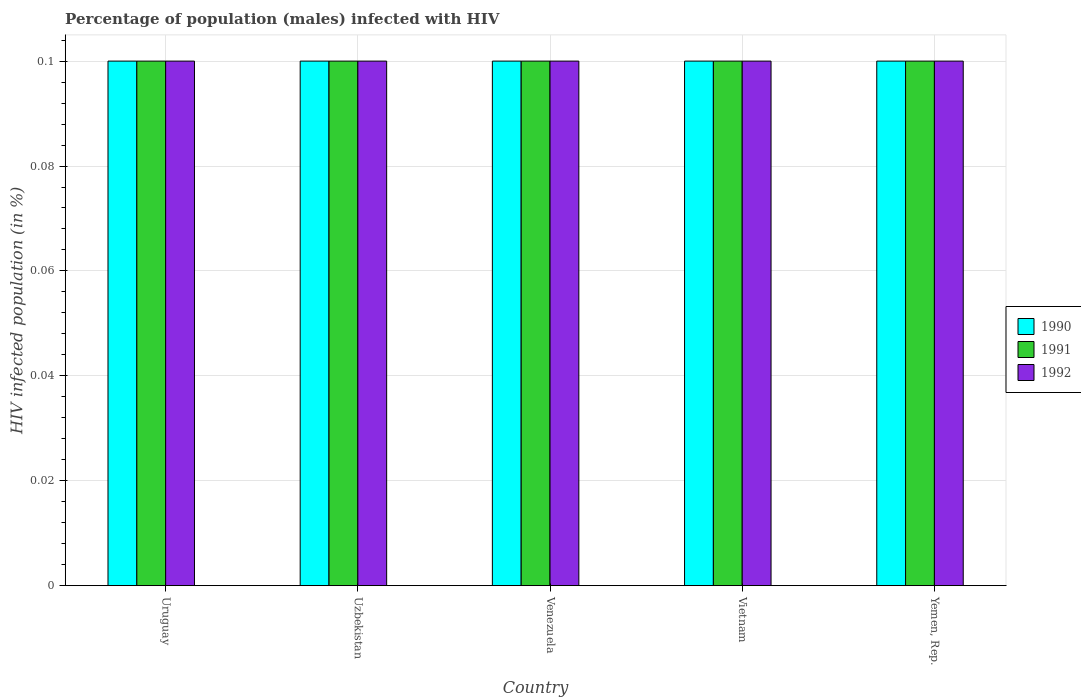How many different coloured bars are there?
Keep it short and to the point. 3. How many bars are there on the 1st tick from the left?
Keep it short and to the point. 3. What is the label of the 4th group of bars from the left?
Offer a terse response. Vietnam. What is the percentage of HIV infected male population in 1991 in Uruguay?
Make the answer very short. 0.1. Across all countries, what is the maximum percentage of HIV infected male population in 1991?
Offer a terse response. 0.1. In which country was the percentage of HIV infected male population in 1991 maximum?
Offer a very short reply. Uruguay. In which country was the percentage of HIV infected male population in 1991 minimum?
Ensure brevity in your answer.  Uruguay. What is the difference between the percentage of HIV infected male population in 1992 in Venezuela and that in Vietnam?
Make the answer very short. 0. What is the average percentage of HIV infected male population in 1992 per country?
Offer a terse response. 0.1. What is the difference between the percentage of HIV infected male population of/in 1992 and percentage of HIV infected male population of/in 1990 in Venezuela?
Ensure brevity in your answer.  0. Is the difference between the percentage of HIV infected male population in 1992 in Venezuela and Yemen, Rep. greater than the difference between the percentage of HIV infected male population in 1990 in Venezuela and Yemen, Rep.?
Offer a terse response. No. In how many countries, is the percentage of HIV infected male population in 1990 greater than the average percentage of HIV infected male population in 1990 taken over all countries?
Your answer should be compact. 0. Is the sum of the percentage of HIV infected male population in 1990 in Vietnam and Yemen, Rep. greater than the maximum percentage of HIV infected male population in 1992 across all countries?
Offer a terse response. Yes. Does the graph contain grids?
Your response must be concise. Yes. How many legend labels are there?
Your response must be concise. 3. How are the legend labels stacked?
Your answer should be very brief. Vertical. What is the title of the graph?
Your answer should be very brief. Percentage of population (males) infected with HIV. What is the label or title of the X-axis?
Provide a short and direct response. Country. What is the label or title of the Y-axis?
Give a very brief answer. HIV infected population (in %). What is the HIV infected population (in %) of 1990 in Uruguay?
Ensure brevity in your answer.  0.1. What is the HIV infected population (in %) in 1991 in Uruguay?
Give a very brief answer. 0.1. What is the HIV infected population (in %) of 1992 in Uruguay?
Provide a short and direct response. 0.1. What is the HIV infected population (in %) in 1992 in Uzbekistan?
Offer a very short reply. 0.1. What is the HIV infected population (in %) in 1992 in Venezuela?
Provide a succinct answer. 0.1. Across all countries, what is the maximum HIV infected population (in %) of 1990?
Make the answer very short. 0.1. Across all countries, what is the minimum HIV infected population (in %) in 1990?
Provide a short and direct response. 0.1. Across all countries, what is the minimum HIV infected population (in %) of 1991?
Your answer should be compact. 0.1. Across all countries, what is the minimum HIV infected population (in %) of 1992?
Ensure brevity in your answer.  0.1. What is the total HIV infected population (in %) in 1990 in the graph?
Provide a short and direct response. 0.5. What is the total HIV infected population (in %) in 1991 in the graph?
Keep it short and to the point. 0.5. What is the difference between the HIV infected population (in %) of 1990 in Uruguay and that in Uzbekistan?
Give a very brief answer. 0. What is the difference between the HIV infected population (in %) of 1992 in Uruguay and that in Venezuela?
Your answer should be very brief. 0. What is the difference between the HIV infected population (in %) in 1991 in Uruguay and that in Vietnam?
Your answer should be compact. 0. What is the difference between the HIV infected population (in %) in 1990 in Uruguay and that in Yemen, Rep.?
Offer a very short reply. 0. What is the difference between the HIV infected population (in %) of 1990 in Uzbekistan and that in Venezuela?
Keep it short and to the point. 0. What is the difference between the HIV infected population (in %) of 1990 in Uzbekistan and that in Vietnam?
Keep it short and to the point. 0. What is the difference between the HIV infected population (in %) of 1991 in Uzbekistan and that in Vietnam?
Offer a very short reply. 0. What is the difference between the HIV infected population (in %) of 1992 in Venezuela and that in Vietnam?
Give a very brief answer. 0. What is the difference between the HIV infected population (in %) in 1992 in Venezuela and that in Yemen, Rep.?
Make the answer very short. 0. What is the difference between the HIV infected population (in %) in 1990 in Vietnam and that in Yemen, Rep.?
Provide a succinct answer. 0. What is the difference between the HIV infected population (in %) in 1991 in Vietnam and that in Yemen, Rep.?
Keep it short and to the point. 0. What is the difference between the HIV infected population (in %) of 1990 in Uruguay and the HIV infected population (in %) of 1991 in Uzbekistan?
Offer a terse response. 0. What is the difference between the HIV infected population (in %) of 1990 in Uruguay and the HIV infected population (in %) of 1992 in Uzbekistan?
Your answer should be very brief. 0. What is the difference between the HIV infected population (in %) in 1991 in Uruguay and the HIV infected population (in %) in 1992 in Uzbekistan?
Give a very brief answer. 0. What is the difference between the HIV infected population (in %) in 1990 in Uruguay and the HIV infected population (in %) in 1991 in Venezuela?
Ensure brevity in your answer.  0. What is the difference between the HIV infected population (in %) of 1990 in Uruguay and the HIV infected population (in %) of 1992 in Vietnam?
Your response must be concise. 0. What is the difference between the HIV infected population (in %) of 1991 in Uruguay and the HIV infected population (in %) of 1992 in Vietnam?
Provide a succinct answer. 0. What is the difference between the HIV infected population (in %) of 1990 in Uruguay and the HIV infected population (in %) of 1991 in Yemen, Rep.?
Provide a short and direct response. 0. What is the difference between the HIV infected population (in %) in 1990 in Uruguay and the HIV infected population (in %) in 1992 in Yemen, Rep.?
Provide a short and direct response. 0. What is the difference between the HIV infected population (in %) of 1990 in Uzbekistan and the HIV infected population (in %) of 1991 in Venezuela?
Your response must be concise. 0. What is the difference between the HIV infected population (in %) in 1990 in Uzbekistan and the HIV infected population (in %) in 1992 in Venezuela?
Make the answer very short. 0. What is the difference between the HIV infected population (in %) in 1990 in Uzbekistan and the HIV infected population (in %) in 1991 in Vietnam?
Your response must be concise. 0. What is the difference between the HIV infected population (in %) of 1990 in Uzbekistan and the HIV infected population (in %) of 1992 in Vietnam?
Your response must be concise. 0. What is the difference between the HIV infected population (in %) of 1990 in Uzbekistan and the HIV infected population (in %) of 1992 in Yemen, Rep.?
Ensure brevity in your answer.  0. What is the difference between the HIV infected population (in %) of 1991 in Uzbekistan and the HIV infected population (in %) of 1992 in Yemen, Rep.?
Your response must be concise. 0. What is the difference between the HIV infected population (in %) of 1990 in Venezuela and the HIV infected population (in %) of 1992 in Vietnam?
Your answer should be compact. 0. What is the difference between the HIV infected population (in %) in 1990 in Vietnam and the HIV infected population (in %) in 1991 in Yemen, Rep.?
Offer a very short reply. 0. What is the average HIV infected population (in %) in 1990 per country?
Your answer should be very brief. 0.1. What is the average HIV infected population (in %) in 1991 per country?
Your answer should be compact. 0.1. What is the difference between the HIV infected population (in %) of 1990 and HIV infected population (in %) of 1991 in Uruguay?
Provide a short and direct response. 0. What is the difference between the HIV infected population (in %) in 1990 and HIV infected population (in %) in 1992 in Uruguay?
Give a very brief answer. 0. What is the difference between the HIV infected population (in %) of 1991 and HIV infected population (in %) of 1992 in Uruguay?
Keep it short and to the point. 0. What is the difference between the HIV infected population (in %) of 1991 and HIV infected population (in %) of 1992 in Uzbekistan?
Your answer should be very brief. 0. What is the difference between the HIV infected population (in %) in 1990 and HIV infected population (in %) in 1992 in Venezuela?
Offer a very short reply. 0. What is the difference between the HIV infected population (in %) in 1991 and HIV infected population (in %) in 1992 in Venezuela?
Offer a terse response. 0. What is the difference between the HIV infected population (in %) in 1990 and HIV infected population (in %) in 1991 in Yemen, Rep.?
Your answer should be very brief. 0. What is the difference between the HIV infected population (in %) of 1991 and HIV infected population (in %) of 1992 in Yemen, Rep.?
Ensure brevity in your answer.  0. What is the ratio of the HIV infected population (in %) in 1990 in Uruguay to that in Venezuela?
Keep it short and to the point. 1. What is the ratio of the HIV infected population (in %) in 1991 in Uruguay to that in Venezuela?
Keep it short and to the point. 1. What is the ratio of the HIV infected population (in %) in 1992 in Uruguay to that in Venezuela?
Ensure brevity in your answer.  1. What is the ratio of the HIV infected population (in %) in 1990 in Uruguay to that in Vietnam?
Your response must be concise. 1. What is the ratio of the HIV infected population (in %) of 1990 in Uruguay to that in Yemen, Rep.?
Keep it short and to the point. 1. What is the ratio of the HIV infected population (in %) of 1992 in Uruguay to that in Yemen, Rep.?
Give a very brief answer. 1. What is the ratio of the HIV infected population (in %) of 1991 in Uzbekistan to that in Vietnam?
Offer a very short reply. 1. What is the ratio of the HIV infected population (in %) in 1992 in Uzbekistan to that in Vietnam?
Offer a very short reply. 1. What is the ratio of the HIV infected population (in %) in 1992 in Uzbekistan to that in Yemen, Rep.?
Offer a very short reply. 1. What is the ratio of the HIV infected population (in %) in 1992 in Venezuela to that in Vietnam?
Keep it short and to the point. 1. What is the ratio of the HIV infected population (in %) of 1990 in Venezuela to that in Yemen, Rep.?
Your answer should be compact. 1. What is the ratio of the HIV infected population (in %) in 1990 in Vietnam to that in Yemen, Rep.?
Provide a succinct answer. 1. What is the ratio of the HIV infected population (in %) in 1991 in Vietnam to that in Yemen, Rep.?
Your answer should be compact. 1. What is the ratio of the HIV infected population (in %) in 1992 in Vietnam to that in Yemen, Rep.?
Provide a succinct answer. 1. What is the difference between the highest and the second highest HIV infected population (in %) of 1990?
Provide a succinct answer. 0. What is the difference between the highest and the second highest HIV infected population (in %) of 1991?
Your response must be concise. 0. What is the difference between the highest and the second highest HIV infected population (in %) of 1992?
Provide a succinct answer. 0. 